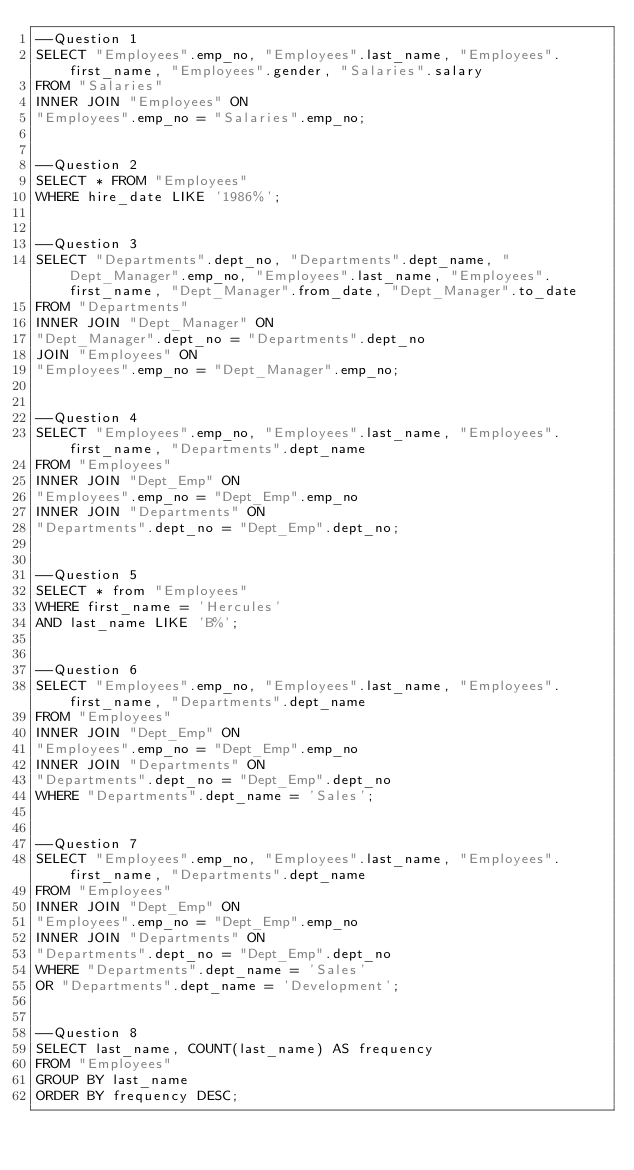<code> <loc_0><loc_0><loc_500><loc_500><_SQL_>--Question 1
SELECT "Employees".emp_no, "Employees".last_name, "Employees".first_name, "Employees".gender, "Salaries".salary
FROM "Salaries"
INNER JOIN "Employees" ON 
"Employees".emp_no = "Salaries".emp_no;


--Question 2
SELECT * FROM "Employees"
WHERE hire_date LIKE '1986%';


--Question 3
SELECT "Departments".dept_no, "Departments".dept_name, "Dept_Manager".emp_no, "Employees".last_name, "Employees".first_name, "Dept_Manager".from_date, "Dept_Manager".to_date
FROM "Departments"
INNER JOIN "Dept_Manager" ON
"Dept_Manager".dept_no = "Departments".dept_no
JOIN "Employees" ON
"Employees".emp_no = "Dept_Manager".emp_no;


--Question 4
SELECT "Employees".emp_no, "Employees".last_name, "Employees".first_name, "Departments".dept_name
FROM "Employees"
INNER JOIN "Dept_Emp" ON
"Employees".emp_no = "Dept_Emp".emp_no
INNER JOIN "Departments" ON 
"Departments".dept_no = "Dept_Emp".dept_no;


--Question 5
SELECT * from "Employees"
WHERE first_name = 'Hercules'
AND last_name LIKE 'B%';


--Question 6
SELECT "Employees".emp_no, "Employees".last_name, "Employees".first_name, "Departments".dept_name
FROM "Employees"
INNER JOIN "Dept_Emp" ON
"Employees".emp_no = "Dept_Emp".emp_no
INNER JOIN "Departments" ON 
"Departments".dept_no = "Dept_Emp".dept_no
WHERE "Departments".dept_name = 'Sales';


--Question 7
SELECT "Employees".emp_no, "Employees".last_name, "Employees".first_name, "Departments".dept_name
FROM "Employees"
INNER JOIN "Dept_Emp" ON
"Employees".emp_no = "Dept_Emp".emp_no
INNER JOIN "Departments" ON 
"Departments".dept_no = "Dept_Emp".dept_no
WHERE "Departments".dept_name = 'Sales'
OR "Departments".dept_name = 'Development';


--Question 8
SELECT last_name, COUNT(last_name) AS frequency
FROM "Employees"
GROUP BY last_name
ORDER BY frequency DESC;




</code> 